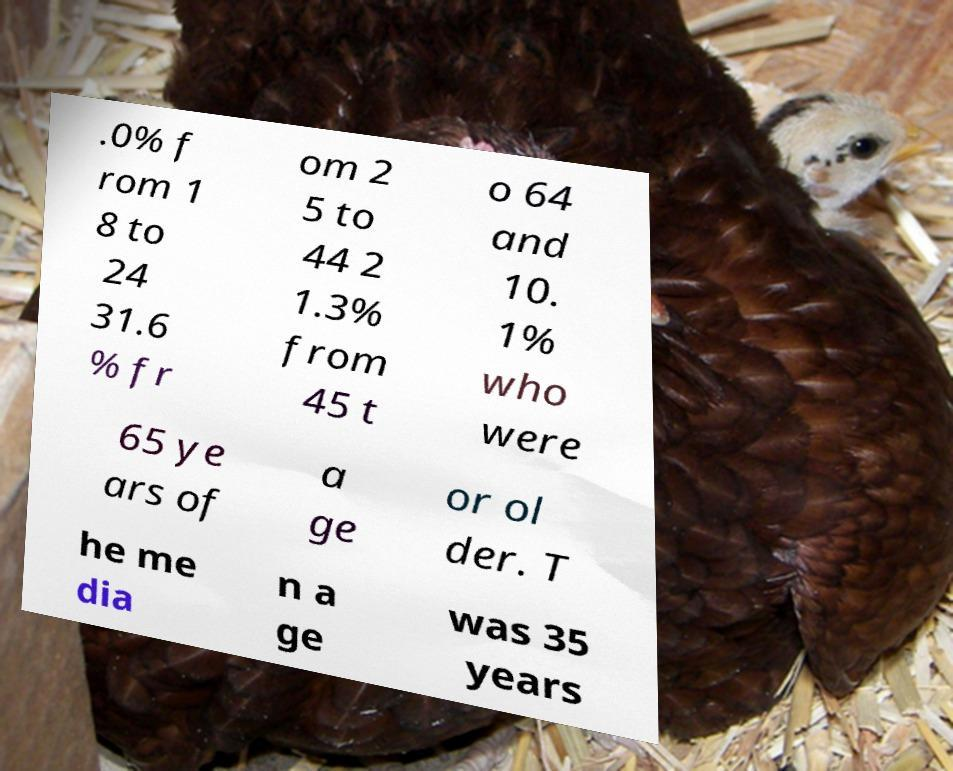For documentation purposes, I need the text within this image transcribed. Could you provide that? .0% f rom 1 8 to 24 31.6 % fr om 2 5 to 44 2 1.3% from 45 t o 64 and 10. 1% who were 65 ye ars of a ge or ol der. T he me dia n a ge was 35 years 